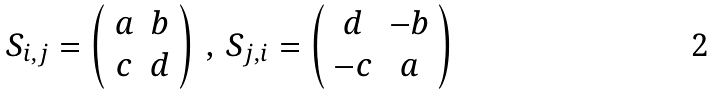Convert formula to latex. <formula><loc_0><loc_0><loc_500><loc_500>S _ { i , j } = \left ( \begin{array} { c c } a & b \\ c & d \end{array} \right ) \, , \, S _ { j , i } = \left ( \begin{array} { c c } d & - b \\ - c & a \end{array} \right )</formula> 